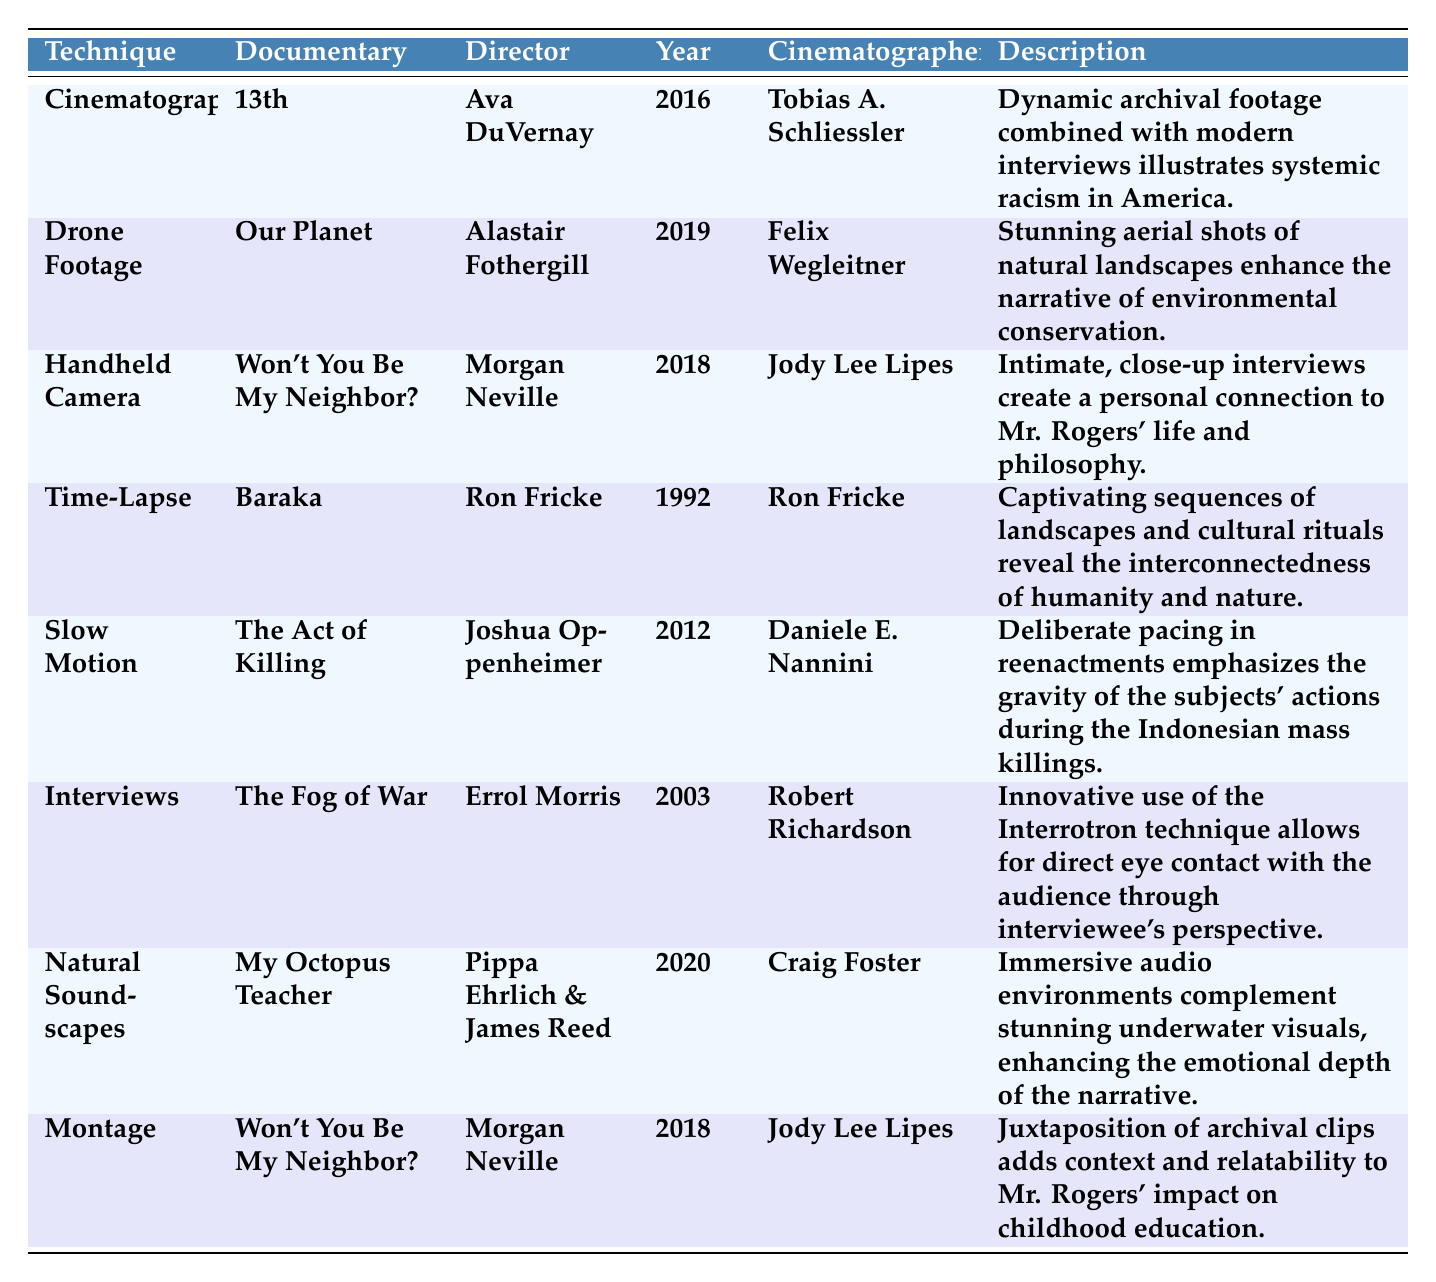What cinematography technique is used in the documentary "13th"? The table clearly lists the documentary "13th" under the "Documentary" column, and the corresponding "Technique" column shows that the technique used is "Cinematography."
Answer: Cinematography Who is the director of "Our Planet"? The documentary "Our Planet" is located in the table where the "Director" column indicates that Alastair Fothergill is the director.
Answer: Alastair Fothergill How many documentaries employ the handheld camera technique? By examining the "Technique" column, we can count the entries labeled "Handheld Camera." There’s one entry for "Won't You Be My Neighbor?" which means there's one documentary that employs this technique.
Answer: 1 In which year was "The Act of Killing" released? The table specifies the year of release for "The Act of Killing" in the "Year" column. It clearly states that it was released in 2012.
Answer: 2012 What is the cinematographer's name for "My Octopus Teacher"? The corresponding row for "My Octopus Teacher" indicates that the cinematographer is Craig Foster, as shown in the "Cinematographer" column.
Answer: Craig Foster Which technique is used in "The Fog of War"? The table mentions the documentary "The Fog of War," and the "Technique" column reveals it uses the "Interviews" technique.
Answer: Interviews Is drone footage used in any documentary listed in the table? The table confirms that drone footage is indeed a technique used, as seen in the entry for "Our Planet." Therefore, the answer is yes.
Answer: Yes What two techniques are used in "Won't You Be My Neighbor?" The table shows two entries for "Won't You Be My Neighbor?" indicating that both "Handheld Camera" and "Montage" techniques are used.
Answer: Handheld Camera and Montage Which documentary features slow-motion and who was the cinematographer? The entry for “The Act of Killing” reveals that slow motion is the technique used, and Daniele E. Nannini is listed as the cinematographer in the respective columns.
Answer: The Act of Killing, Daniele E. Nannini What is the primary theme illustrated in "13th" and what technique is employed for it? According to the table, "13th" illustrates systemic racism in America utilizing the technique of "Cinematography." This can be deduced from the corresponding description.
Answer: Systemic racism, Cinematography How many different cinematography techniques are listed in total in the table? By counting each unique entry in the "Technique" column, we find there are 7 different techniques (Cinematography, Drone Footage, Handheld Camera, Time-Lapse, Slow Motion, Interviews, Natural Soundscapes, and Montage).
Answer: 7 Which brings together historical footage and modern interviews? The table indicates that "13th" incorporates "Dynamic archival footage combined with modern interviews" under its description, clearly linking it to the respective technique of "Cinematography."
Answer: 13th 